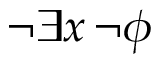Convert formula to latex. <formula><loc_0><loc_0><loc_500><loc_500>\neg \exists x \, \neg \phi</formula> 